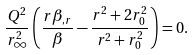Convert formula to latex. <formula><loc_0><loc_0><loc_500><loc_500>\frac { Q ^ { 2 } } { r _ { \infty } ^ { 2 } } \left ( \frac { r \beta _ { , r } } { \beta } - \frac { r ^ { 2 } + 2 r _ { 0 } ^ { 2 } } { r ^ { 2 } + r _ { 0 } ^ { 2 } } \right ) = 0 .</formula> 